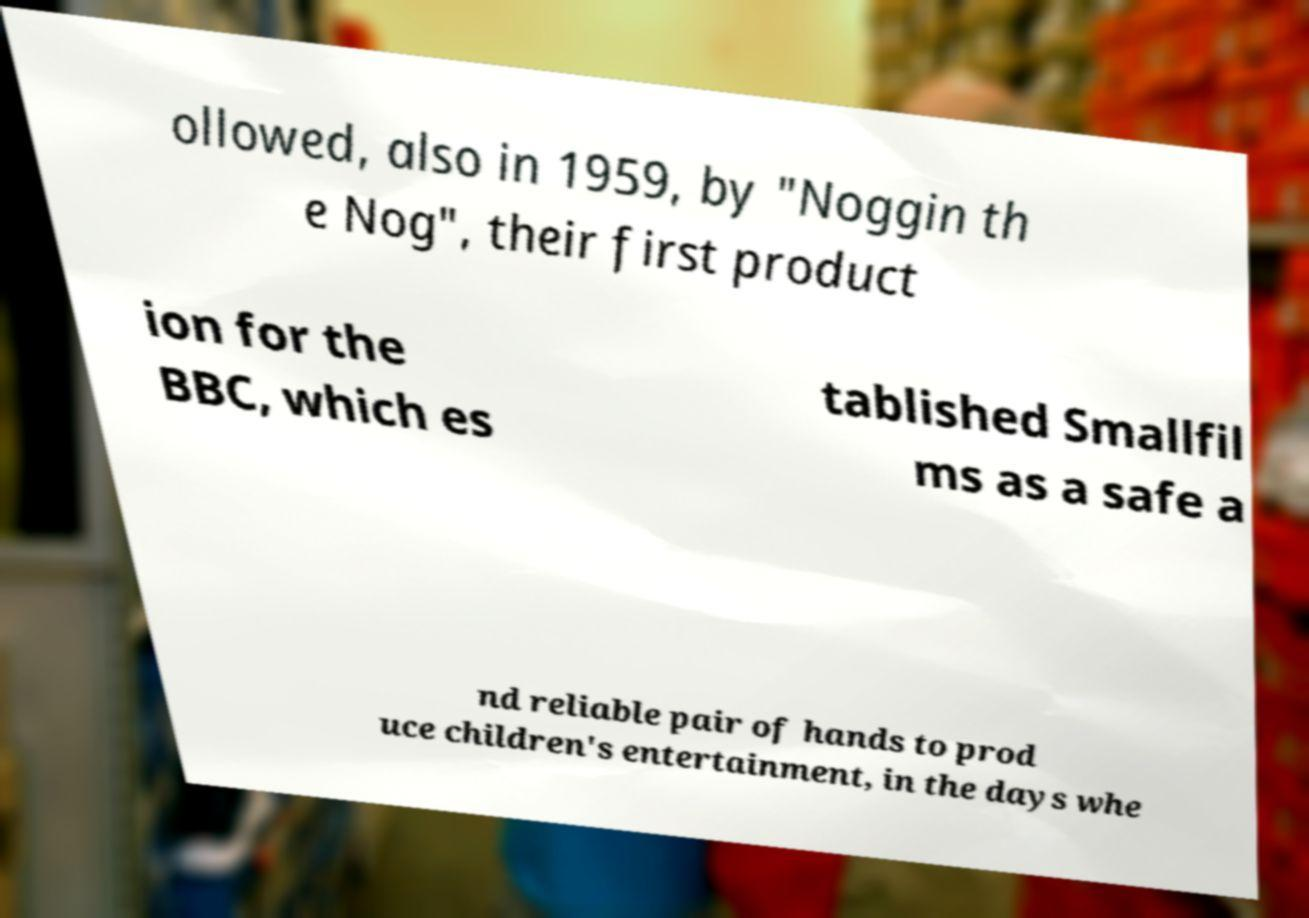I need the written content from this picture converted into text. Can you do that? ollowed, also in 1959, by "Noggin th e Nog", their first product ion for the BBC, which es tablished Smallfil ms as a safe a nd reliable pair of hands to prod uce children's entertainment, in the days whe 